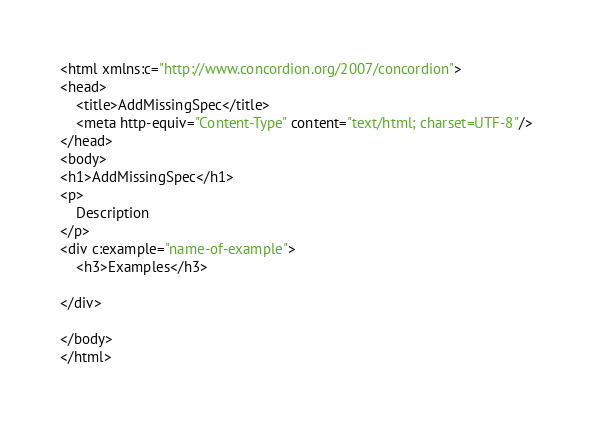Convert code to text. <code><loc_0><loc_0><loc_500><loc_500><_HTML_><html xmlns:c="http://www.concordion.org/2007/concordion">
<head>
    <title>AddMissingSpec</title>
    <meta http-equiv="Content-Type" content="text/html; charset=UTF-8"/>
</head>
<body>
<h1>AddMissingSpec</h1>
<p>
    Description
</p>
<div c:example="name-of-example">
    <h3>Examples</h3>

</div>

</body>
</html>
</code> 